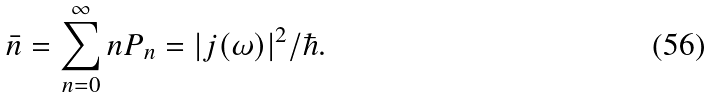<formula> <loc_0><loc_0><loc_500><loc_500>\bar { n } = \sum _ { n = 0 } ^ { \infty } n P _ { n } = | j ( \omega ) | ^ { 2 } / \hbar { . }</formula> 